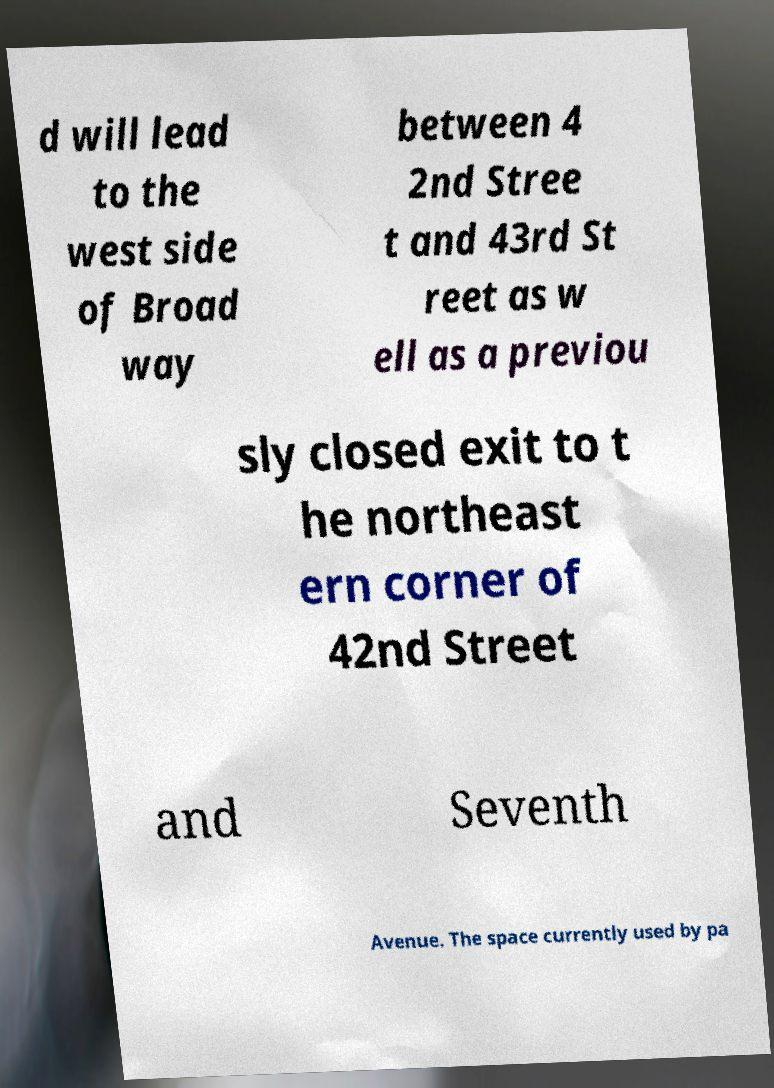Please read and relay the text visible in this image. What does it say? d will lead to the west side of Broad way between 4 2nd Stree t and 43rd St reet as w ell as a previou sly closed exit to t he northeast ern corner of 42nd Street and Seventh Avenue. The space currently used by pa 